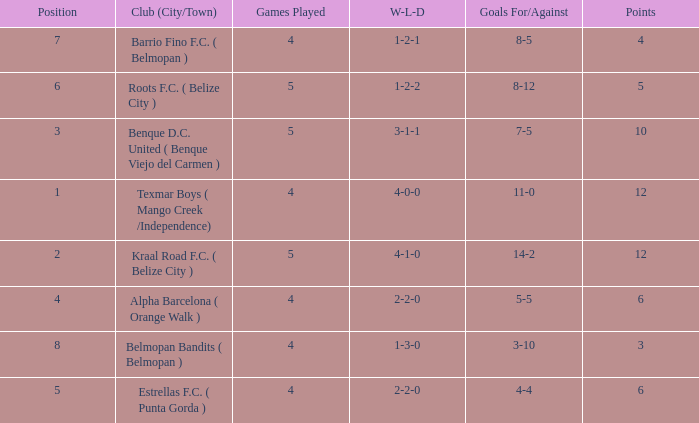Who is the the club (city/town) with goals for/against being 14-2 Kraal Road F.C. ( Belize City ). 